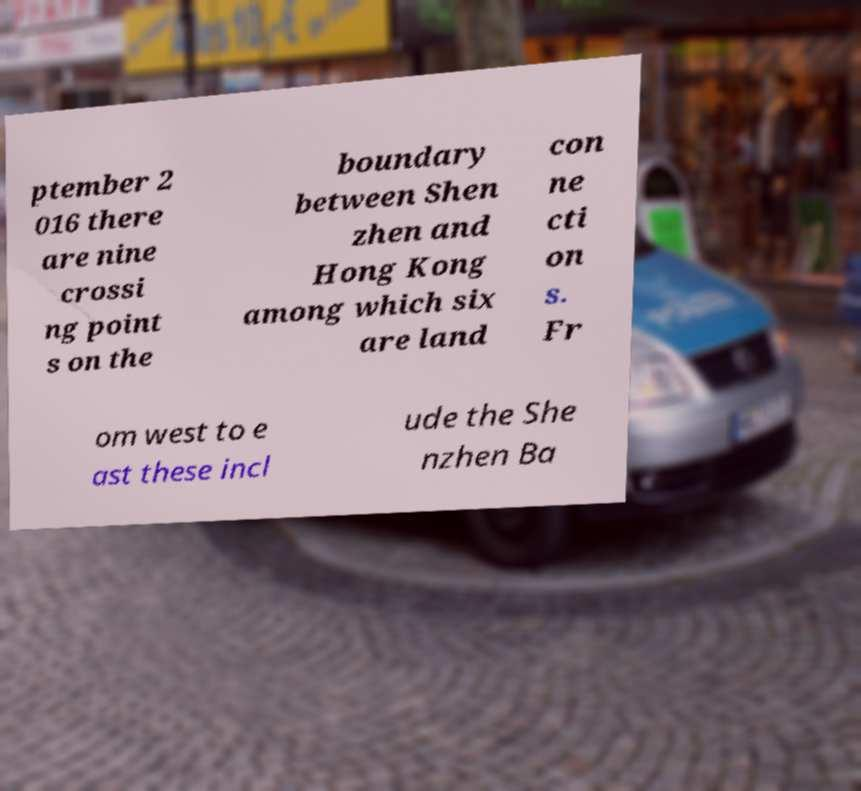I need the written content from this picture converted into text. Can you do that? ptember 2 016 there are nine crossi ng point s on the boundary between Shen zhen and Hong Kong among which six are land con ne cti on s. Fr om west to e ast these incl ude the She nzhen Ba 